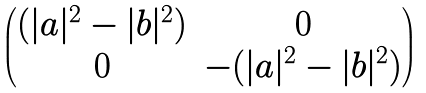Convert formula to latex. <formula><loc_0><loc_0><loc_500><loc_500>\begin{pmatrix} ( | a | ^ { 2 } - | b | ^ { 2 } ) & 0 \\ 0 & - ( | a | ^ { 2 } - | b | ^ { 2 } ) \end{pmatrix}</formula> 